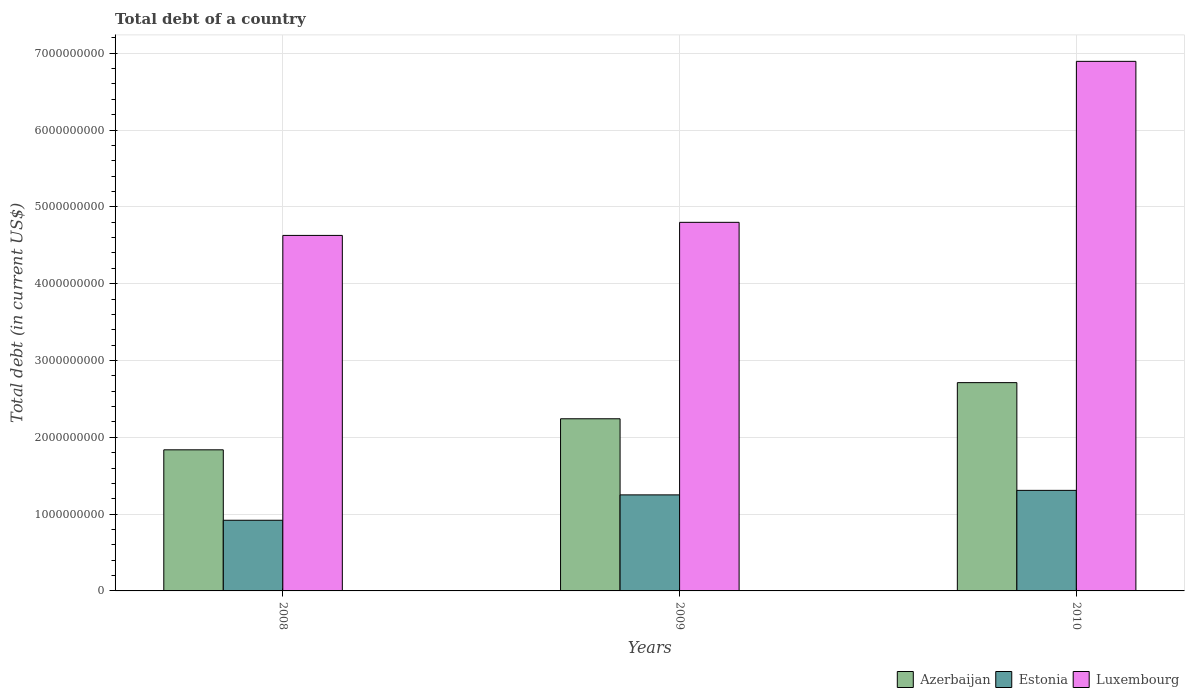How many different coloured bars are there?
Offer a terse response. 3. How many bars are there on the 2nd tick from the left?
Your answer should be compact. 3. How many bars are there on the 3rd tick from the right?
Keep it short and to the point. 3. In how many cases, is the number of bars for a given year not equal to the number of legend labels?
Offer a terse response. 0. What is the debt in Azerbaijan in 2010?
Your answer should be compact. 2.71e+09. Across all years, what is the maximum debt in Estonia?
Your response must be concise. 1.31e+09. Across all years, what is the minimum debt in Luxembourg?
Provide a succinct answer. 4.63e+09. In which year was the debt in Luxembourg maximum?
Provide a succinct answer. 2010. What is the total debt in Luxembourg in the graph?
Your response must be concise. 1.63e+1. What is the difference between the debt in Luxembourg in 2008 and that in 2010?
Ensure brevity in your answer.  -2.27e+09. What is the difference between the debt in Azerbaijan in 2008 and the debt in Estonia in 2010?
Offer a terse response. 5.28e+08. What is the average debt in Azerbaijan per year?
Give a very brief answer. 2.26e+09. In the year 2009, what is the difference between the debt in Azerbaijan and debt in Estonia?
Make the answer very short. 9.91e+08. What is the ratio of the debt in Estonia in 2008 to that in 2009?
Provide a short and direct response. 0.74. Is the debt in Luxembourg in 2009 less than that in 2010?
Ensure brevity in your answer.  Yes. What is the difference between the highest and the second highest debt in Estonia?
Offer a terse response. 5.88e+07. What is the difference between the highest and the lowest debt in Azerbaijan?
Your answer should be very brief. 8.75e+08. In how many years, is the debt in Azerbaijan greater than the average debt in Azerbaijan taken over all years?
Your response must be concise. 1. What does the 2nd bar from the left in 2008 represents?
Your response must be concise. Estonia. What does the 1st bar from the right in 2010 represents?
Offer a terse response. Luxembourg. Is it the case that in every year, the sum of the debt in Luxembourg and debt in Azerbaijan is greater than the debt in Estonia?
Offer a terse response. Yes. Are all the bars in the graph horizontal?
Your response must be concise. No. How many years are there in the graph?
Your answer should be very brief. 3. What is the difference between two consecutive major ticks on the Y-axis?
Make the answer very short. 1.00e+09. Does the graph contain any zero values?
Offer a very short reply. No. How many legend labels are there?
Provide a short and direct response. 3. What is the title of the graph?
Ensure brevity in your answer.  Total debt of a country. What is the label or title of the X-axis?
Offer a terse response. Years. What is the label or title of the Y-axis?
Give a very brief answer. Total debt (in current US$). What is the Total debt (in current US$) of Azerbaijan in 2008?
Give a very brief answer. 1.84e+09. What is the Total debt (in current US$) in Estonia in 2008?
Give a very brief answer. 9.20e+08. What is the Total debt (in current US$) of Luxembourg in 2008?
Offer a terse response. 4.63e+09. What is the Total debt (in current US$) of Azerbaijan in 2009?
Give a very brief answer. 2.24e+09. What is the Total debt (in current US$) in Estonia in 2009?
Your response must be concise. 1.25e+09. What is the Total debt (in current US$) in Luxembourg in 2009?
Offer a very short reply. 4.80e+09. What is the Total debt (in current US$) in Azerbaijan in 2010?
Give a very brief answer. 2.71e+09. What is the Total debt (in current US$) in Estonia in 2010?
Provide a succinct answer. 1.31e+09. What is the Total debt (in current US$) of Luxembourg in 2010?
Your answer should be compact. 6.89e+09. Across all years, what is the maximum Total debt (in current US$) in Azerbaijan?
Your response must be concise. 2.71e+09. Across all years, what is the maximum Total debt (in current US$) in Estonia?
Offer a terse response. 1.31e+09. Across all years, what is the maximum Total debt (in current US$) of Luxembourg?
Your answer should be very brief. 6.89e+09. Across all years, what is the minimum Total debt (in current US$) in Azerbaijan?
Make the answer very short. 1.84e+09. Across all years, what is the minimum Total debt (in current US$) in Estonia?
Provide a short and direct response. 9.20e+08. Across all years, what is the minimum Total debt (in current US$) of Luxembourg?
Offer a very short reply. 4.63e+09. What is the total Total debt (in current US$) of Azerbaijan in the graph?
Make the answer very short. 6.79e+09. What is the total Total debt (in current US$) of Estonia in the graph?
Your response must be concise. 3.48e+09. What is the total Total debt (in current US$) of Luxembourg in the graph?
Give a very brief answer. 1.63e+1. What is the difference between the Total debt (in current US$) in Azerbaijan in 2008 and that in 2009?
Your answer should be very brief. -4.04e+08. What is the difference between the Total debt (in current US$) of Estonia in 2008 and that in 2009?
Your response must be concise. -3.30e+08. What is the difference between the Total debt (in current US$) of Luxembourg in 2008 and that in 2009?
Make the answer very short. -1.70e+08. What is the difference between the Total debt (in current US$) of Azerbaijan in 2008 and that in 2010?
Offer a terse response. -8.75e+08. What is the difference between the Total debt (in current US$) in Estonia in 2008 and that in 2010?
Make the answer very short. -3.89e+08. What is the difference between the Total debt (in current US$) in Luxembourg in 2008 and that in 2010?
Keep it short and to the point. -2.27e+09. What is the difference between the Total debt (in current US$) of Azerbaijan in 2009 and that in 2010?
Keep it short and to the point. -4.71e+08. What is the difference between the Total debt (in current US$) of Estonia in 2009 and that in 2010?
Offer a very short reply. -5.88e+07. What is the difference between the Total debt (in current US$) in Luxembourg in 2009 and that in 2010?
Offer a terse response. -2.10e+09. What is the difference between the Total debt (in current US$) in Azerbaijan in 2008 and the Total debt (in current US$) in Estonia in 2009?
Make the answer very short. 5.86e+08. What is the difference between the Total debt (in current US$) of Azerbaijan in 2008 and the Total debt (in current US$) of Luxembourg in 2009?
Provide a short and direct response. -2.96e+09. What is the difference between the Total debt (in current US$) of Estonia in 2008 and the Total debt (in current US$) of Luxembourg in 2009?
Your answer should be compact. -3.88e+09. What is the difference between the Total debt (in current US$) in Azerbaijan in 2008 and the Total debt (in current US$) in Estonia in 2010?
Your answer should be compact. 5.28e+08. What is the difference between the Total debt (in current US$) of Azerbaijan in 2008 and the Total debt (in current US$) of Luxembourg in 2010?
Make the answer very short. -5.06e+09. What is the difference between the Total debt (in current US$) in Estonia in 2008 and the Total debt (in current US$) in Luxembourg in 2010?
Give a very brief answer. -5.97e+09. What is the difference between the Total debt (in current US$) of Azerbaijan in 2009 and the Total debt (in current US$) of Estonia in 2010?
Your answer should be very brief. 9.32e+08. What is the difference between the Total debt (in current US$) of Azerbaijan in 2009 and the Total debt (in current US$) of Luxembourg in 2010?
Offer a very short reply. -4.65e+09. What is the difference between the Total debt (in current US$) in Estonia in 2009 and the Total debt (in current US$) in Luxembourg in 2010?
Ensure brevity in your answer.  -5.64e+09. What is the average Total debt (in current US$) of Azerbaijan per year?
Provide a succinct answer. 2.26e+09. What is the average Total debt (in current US$) of Estonia per year?
Provide a short and direct response. 1.16e+09. What is the average Total debt (in current US$) in Luxembourg per year?
Offer a terse response. 5.44e+09. In the year 2008, what is the difference between the Total debt (in current US$) of Azerbaijan and Total debt (in current US$) of Estonia?
Provide a short and direct response. 9.17e+08. In the year 2008, what is the difference between the Total debt (in current US$) in Azerbaijan and Total debt (in current US$) in Luxembourg?
Offer a very short reply. -2.79e+09. In the year 2008, what is the difference between the Total debt (in current US$) of Estonia and Total debt (in current US$) of Luxembourg?
Provide a short and direct response. -3.71e+09. In the year 2009, what is the difference between the Total debt (in current US$) of Azerbaijan and Total debt (in current US$) of Estonia?
Your answer should be very brief. 9.91e+08. In the year 2009, what is the difference between the Total debt (in current US$) in Azerbaijan and Total debt (in current US$) in Luxembourg?
Provide a short and direct response. -2.56e+09. In the year 2009, what is the difference between the Total debt (in current US$) of Estonia and Total debt (in current US$) of Luxembourg?
Provide a succinct answer. -3.55e+09. In the year 2010, what is the difference between the Total debt (in current US$) of Azerbaijan and Total debt (in current US$) of Estonia?
Your answer should be very brief. 1.40e+09. In the year 2010, what is the difference between the Total debt (in current US$) of Azerbaijan and Total debt (in current US$) of Luxembourg?
Provide a succinct answer. -4.18e+09. In the year 2010, what is the difference between the Total debt (in current US$) in Estonia and Total debt (in current US$) in Luxembourg?
Keep it short and to the point. -5.59e+09. What is the ratio of the Total debt (in current US$) of Azerbaijan in 2008 to that in 2009?
Your answer should be compact. 0.82. What is the ratio of the Total debt (in current US$) in Estonia in 2008 to that in 2009?
Give a very brief answer. 0.74. What is the ratio of the Total debt (in current US$) in Luxembourg in 2008 to that in 2009?
Your answer should be compact. 0.96. What is the ratio of the Total debt (in current US$) in Azerbaijan in 2008 to that in 2010?
Your response must be concise. 0.68. What is the ratio of the Total debt (in current US$) in Estonia in 2008 to that in 2010?
Offer a very short reply. 0.7. What is the ratio of the Total debt (in current US$) of Luxembourg in 2008 to that in 2010?
Your answer should be very brief. 0.67. What is the ratio of the Total debt (in current US$) of Azerbaijan in 2009 to that in 2010?
Provide a short and direct response. 0.83. What is the ratio of the Total debt (in current US$) of Estonia in 2009 to that in 2010?
Provide a short and direct response. 0.96. What is the ratio of the Total debt (in current US$) in Luxembourg in 2009 to that in 2010?
Your answer should be compact. 0.7. What is the difference between the highest and the second highest Total debt (in current US$) of Azerbaijan?
Provide a short and direct response. 4.71e+08. What is the difference between the highest and the second highest Total debt (in current US$) in Estonia?
Give a very brief answer. 5.88e+07. What is the difference between the highest and the second highest Total debt (in current US$) of Luxembourg?
Your answer should be very brief. 2.10e+09. What is the difference between the highest and the lowest Total debt (in current US$) in Azerbaijan?
Keep it short and to the point. 8.75e+08. What is the difference between the highest and the lowest Total debt (in current US$) in Estonia?
Offer a terse response. 3.89e+08. What is the difference between the highest and the lowest Total debt (in current US$) of Luxembourg?
Offer a very short reply. 2.27e+09. 